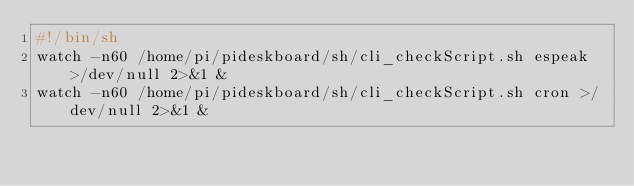Convert code to text. <code><loc_0><loc_0><loc_500><loc_500><_Bash_>#!/bin/sh
watch -n60 /home/pi/pideskboard/sh/cli_checkScript.sh espeak >/dev/null 2>&1 &
watch -n60 /home/pi/pideskboard/sh/cli_checkScript.sh cron >/dev/null 2>&1 &</code> 